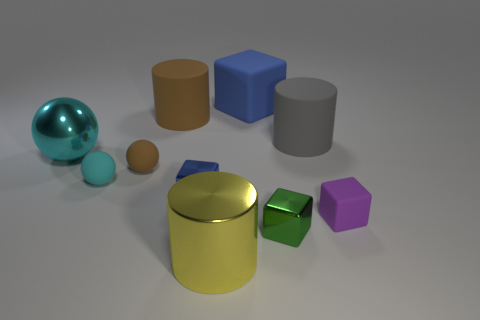Subtract all large yellow cylinders. How many cylinders are left? 2 Subtract all brown balls. How many balls are left? 2 Subtract all brown blocks. Subtract all brown cylinders. How many blocks are left? 4 Subtract all yellow spheres. How many green blocks are left? 1 Add 9 big gray objects. How many big gray objects are left? 10 Add 2 tiny red cylinders. How many tiny red cylinders exist? 2 Subtract 1 cyan spheres. How many objects are left? 9 Subtract all balls. How many objects are left? 7 Subtract 3 spheres. How many spheres are left? 0 Subtract all small cyan rubber spheres. Subtract all tiny blue spheres. How many objects are left? 9 